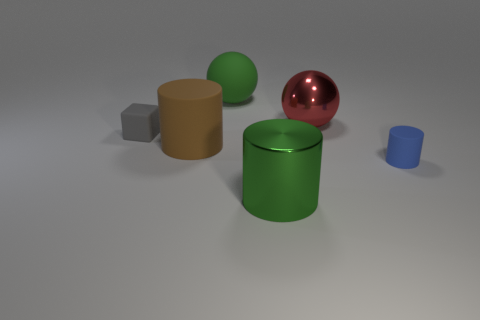There is a object that is the same color as the big rubber sphere; what material is it?
Your response must be concise. Metal. What is the shape of the object on the right side of the big ball that is to the right of the large ball that is left of the big red metallic object?
Give a very brief answer. Cylinder. There is a red thing; what shape is it?
Make the answer very short. Sphere. What is the shape of the gray matte object that is the same size as the blue thing?
Your response must be concise. Cube. How many other objects are there of the same color as the large matte sphere?
Provide a succinct answer. 1. There is a large green thing that is in front of the gray block; is it the same shape as the green object behind the matte cube?
Make the answer very short. No. What number of things are rubber objects to the right of the gray object or green objects that are behind the red metal sphere?
Give a very brief answer. 3. What number of other objects are there of the same material as the red sphere?
Provide a succinct answer. 1. Do the large green cylinder in front of the rubber block and the large red object have the same material?
Provide a succinct answer. Yes. Is the number of rubber things behind the red metallic ball greater than the number of big brown things that are left of the brown matte object?
Your answer should be very brief. Yes. 